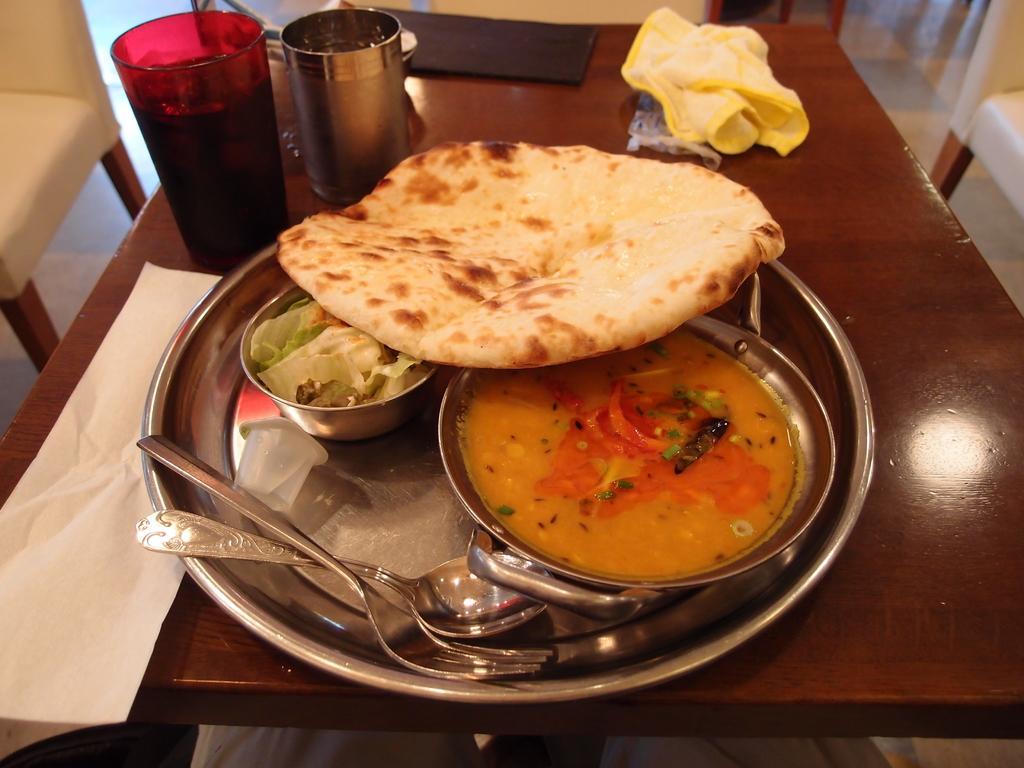In one or two sentences, can you explain what this image depicts? In this image we can see a food item, spoons, bowls, plate, glasses and other objects are present on the table. We can see a chair on the left side of this image and on the right side of this image as well. 